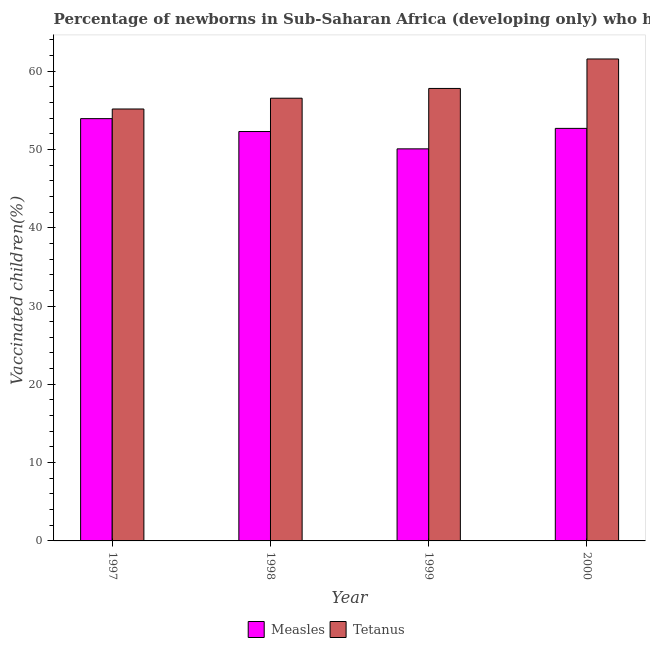How many groups of bars are there?
Provide a short and direct response. 4. Are the number of bars per tick equal to the number of legend labels?
Give a very brief answer. Yes. Are the number of bars on each tick of the X-axis equal?
Ensure brevity in your answer.  Yes. How many bars are there on the 4th tick from the right?
Give a very brief answer. 2. What is the percentage of newborns who received vaccination for tetanus in 1998?
Your response must be concise. 56.54. Across all years, what is the maximum percentage of newborns who received vaccination for tetanus?
Keep it short and to the point. 61.55. Across all years, what is the minimum percentage of newborns who received vaccination for measles?
Provide a short and direct response. 50.07. In which year was the percentage of newborns who received vaccination for tetanus maximum?
Give a very brief answer. 2000. In which year was the percentage of newborns who received vaccination for tetanus minimum?
Give a very brief answer. 1997. What is the total percentage of newborns who received vaccination for tetanus in the graph?
Your response must be concise. 231.03. What is the difference between the percentage of newborns who received vaccination for tetanus in 1999 and that in 2000?
Offer a very short reply. -3.76. What is the difference between the percentage of newborns who received vaccination for tetanus in 1998 and the percentage of newborns who received vaccination for measles in 2000?
Make the answer very short. -5.01. What is the average percentage of newborns who received vaccination for tetanus per year?
Your answer should be compact. 57.76. In the year 1999, what is the difference between the percentage of newborns who received vaccination for measles and percentage of newborns who received vaccination for tetanus?
Your answer should be very brief. 0. In how many years, is the percentage of newborns who received vaccination for measles greater than 26 %?
Your answer should be very brief. 4. What is the ratio of the percentage of newborns who received vaccination for tetanus in 1997 to that in 1999?
Provide a succinct answer. 0.95. Is the percentage of newborns who received vaccination for tetanus in 1998 less than that in 1999?
Offer a very short reply. Yes. Is the difference between the percentage of newborns who received vaccination for tetanus in 1999 and 2000 greater than the difference between the percentage of newborns who received vaccination for measles in 1999 and 2000?
Your answer should be compact. No. What is the difference between the highest and the second highest percentage of newborns who received vaccination for tetanus?
Your response must be concise. 3.76. What is the difference between the highest and the lowest percentage of newborns who received vaccination for tetanus?
Give a very brief answer. 6.39. In how many years, is the percentage of newborns who received vaccination for measles greater than the average percentage of newborns who received vaccination for measles taken over all years?
Offer a terse response. 3. What does the 2nd bar from the left in 1997 represents?
Provide a short and direct response. Tetanus. What does the 1st bar from the right in 1998 represents?
Your answer should be compact. Tetanus. How many bars are there?
Your answer should be very brief. 8. Are all the bars in the graph horizontal?
Keep it short and to the point. No. Are the values on the major ticks of Y-axis written in scientific E-notation?
Your response must be concise. No. How are the legend labels stacked?
Provide a short and direct response. Horizontal. What is the title of the graph?
Offer a terse response. Percentage of newborns in Sub-Saharan Africa (developing only) who have received the vaccination. What is the label or title of the X-axis?
Your answer should be compact. Year. What is the label or title of the Y-axis?
Your answer should be compact. Vaccinated children(%)
. What is the Vaccinated children(%)
 in Measles in 1997?
Offer a very short reply. 53.93. What is the Vaccinated children(%)
 in Tetanus in 1997?
Provide a short and direct response. 55.16. What is the Vaccinated children(%)
 in Measles in 1998?
Keep it short and to the point. 52.28. What is the Vaccinated children(%)
 of Tetanus in 1998?
Make the answer very short. 56.54. What is the Vaccinated children(%)
 of Measles in 1999?
Provide a short and direct response. 50.07. What is the Vaccinated children(%)
 in Tetanus in 1999?
Ensure brevity in your answer.  57.79. What is the Vaccinated children(%)
 of Measles in 2000?
Your response must be concise. 52.68. What is the Vaccinated children(%)
 of Tetanus in 2000?
Make the answer very short. 61.55. Across all years, what is the maximum Vaccinated children(%)
 in Measles?
Provide a succinct answer. 53.93. Across all years, what is the maximum Vaccinated children(%)
 of Tetanus?
Your answer should be very brief. 61.55. Across all years, what is the minimum Vaccinated children(%)
 of Measles?
Provide a short and direct response. 50.07. Across all years, what is the minimum Vaccinated children(%)
 of Tetanus?
Provide a succinct answer. 55.16. What is the total Vaccinated children(%)
 in Measles in the graph?
Ensure brevity in your answer.  208.97. What is the total Vaccinated children(%)
 in Tetanus in the graph?
Your answer should be very brief. 231.03. What is the difference between the Vaccinated children(%)
 in Measles in 1997 and that in 1998?
Offer a very short reply. 1.64. What is the difference between the Vaccinated children(%)
 of Tetanus in 1997 and that in 1998?
Make the answer very short. -1.38. What is the difference between the Vaccinated children(%)
 of Measles in 1997 and that in 1999?
Your response must be concise. 3.86. What is the difference between the Vaccinated children(%)
 of Tetanus in 1997 and that in 1999?
Keep it short and to the point. -2.62. What is the difference between the Vaccinated children(%)
 of Measles in 1997 and that in 2000?
Ensure brevity in your answer.  1.24. What is the difference between the Vaccinated children(%)
 in Tetanus in 1997 and that in 2000?
Your answer should be compact. -6.39. What is the difference between the Vaccinated children(%)
 in Measles in 1998 and that in 1999?
Give a very brief answer. 2.21. What is the difference between the Vaccinated children(%)
 of Tetanus in 1998 and that in 1999?
Offer a terse response. -1.25. What is the difference between the Vaccinated children(%)
 of Measles in 1998 and that in 2000?
Your answer should be compact. -0.4. What is the difference between the Vaccinated children(%)
 in Tetanus in 1998 and that in 2000?
Ensure brevity in your answer.  -5.01. What is the difference between the Vaccinated children(%)
 of Measles in 1999 and that in 2000?
Provide a short and direct response. -2.61. What is the difference between the Vaccinated children(%)
 in Tetanus in 1999 and that in 2000?
Ensure brevity in your answer.  -3.76. What is the difference between the Vaccinated children(%)
 in Measles in 1997 and the Vaccinated children(%)
 in Tetanus in 1998?
Keep it short and to the point. -2.61. What is the difference between the Vaccinated children(%)
 in Measles in 1997 and the Vaccinated children(%)
 in Tetanus in 1999?
Provide a succinct answer. -3.86. What is the difference between the Vaccinated children(%)
 of Measles in 1997 and the Vaccinated children(%)
 of Tetanus in 2000?
Your answer should be compact. -7.62. What is the difference between the Vaccinated children(%)
 in Measles in 1998 and the Vaccinated children(%)
 in Tetanus in 1999?
Your answer should be very brief. -5.5. What is the difference between the Vaccinated children(%)
 in Measles in 1998 and the Vaccinated children(%)
 in Tetanus in 2000?
Provide a short and direct response. -9.26. What is the difference between the Vaccinated children(%)
 in Measles in 1999 and the Vaccinated children(%)
 in Tetanus in 2000?
Ensure brevity in your answer.  -11.48. What is the average Vaccinated children(%)
 of Measles per year?
Your response must be concise. 52.24. What is the average Vaccinated children(%)
 in Tetanus per year?
Offer a very short reply. 57.76. In the year 1997, what is the difference between the Vaccinated children(%)
 of Measles and Vaccinated children(%)
 of Tetanus?
Give a very brief answer. -1.23. In the year 1998, what is the difference between the Vaccinated children(%)
 of Measles and Vaccinated children(%)
 of Tetanus?
Your response must be concise. -4.25. In the year 1999, what is the difference between the Vaccinated children(%)
 in Measles and Vaccinated children(%)
 in Tetanus?
Provide a succinct answer. -7.71. In the year 2000, what is the difference between the Vaccinated children(%)
 in Measles and Vaccinated children(%)
 in Tetanus?
Provide a short and direct response. -8.86. What is the ratio of the Vaccinated children(%)
 in Measles in 1997 to that in 1998?
Your answer should be very brief. 1.03. What is the ratio of the Vaccinated children(%)
 of Tetanus in 1997 to that in 1998?
Your answer should be very brief. 0.98. What is the ratio of the Vaccinated children(%)
 in Measles in 1997 to that in 1999?
Offer a terse response. 1.08. What is the ratio of the Vaccinated children(%)
 in Tetanus in 1997 to that in 1999?
Make the answer very short. 0.95. What is the ratio of the Vaccinated children(%)
 of Measles in 1997 to that in 2000?
Your answer should be compact. 1.02. What is the ratio of the Vaccinated children(%)
 in Tetanus in 1997 to that in 2000?
Make the answer very short. 0.9. What is the ratio of the Vaccinated children(%)
 of Measles in 1998 to that in 1999?
Your answer should be compact. 1.04. What is the ratio of the Vaccinated children(%)
 in Tetanus in 1998 to that in 1999?
Provide a succinct answer. 0.98. What is the ratio of the Vaccinated children(%)
 of Tetanus in 1998 to that in 2000?
Provide a short and direct response. 0.92. What is the ratio of the Vaccinated children(%)
 in Measles in 1999 to that in 2000?
Your response must be concise. 0.95. What is the ratio of the Vaccinated children(%)
 in Tetanus in 1999 to that in 2000?
Make the answer very short. 0.94. What is the difference between the highest and the second highest Vaccinated children(%)
 in Measles?
Ensure brevity in your answer.  1.24. What is the difference between the highest and the second highest Vaccinated children(%)
 in Tetanus?
Offer a very short reply. 3.76. What is the difference between the highest and the lowest Vaccinated children(%)
 in Measles?
Offer a very short reply. 3.86. What is the difference between the highest and the lowest Vaccinated children(%)
 of Tetanus?
Offer a very short reply. 6.39. 